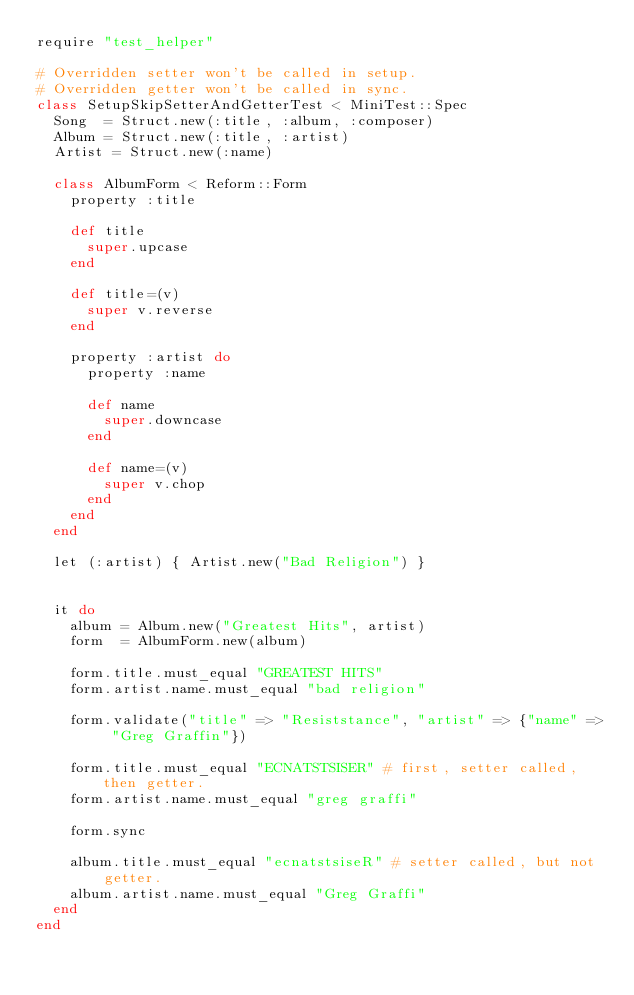Convert code to text. <code><loc_0><loc_0><loc_500><loc_500><_Ruby_>require "test_helper"

# Overridden setter won't be called in setup.
# Overridden getter won't be called in sync.
class SetupSkipSetterAndGetterTest < MiniTest::Spec
  Song  = Struct.new(:title, :album, :composer)
  Album = Struct.new(:title, :artist)
  Artist = Struct.new(:name)

  class AlbumForm < Reform::Form
    property :title

    def title
      super.upcase
    end

    def title=(v)
      super v.reverse
    end

    property :artist do
      property :name

      def name
        super.downcase
      end

      def name=(v)
        super v.chop
      end
    end
  end

  let (:artist) { Artist.new("Bad Religion") }


  it do
    album = Album.new("Greatest Hits", artist)
    form  = AlbumForm.new(album)

    form.title.must_equal "GREATEST HITS"
    form.artist.name.must_equal "bad religion"

    form.validate("title" => "Resiststance", "artist" => {"name" => "Greg Graffin"})

    form.title.must_equal "ECNATSTSISER" # first, setter called, then getter.
    form.artist.name.must_equal "greg graffi"

    form.sync

    album.title.must_equal "ecnatstsiseR" # setter called, but not getter.
    album.artist.name.must_equal "Greg Graffi"
  end
end</code> 